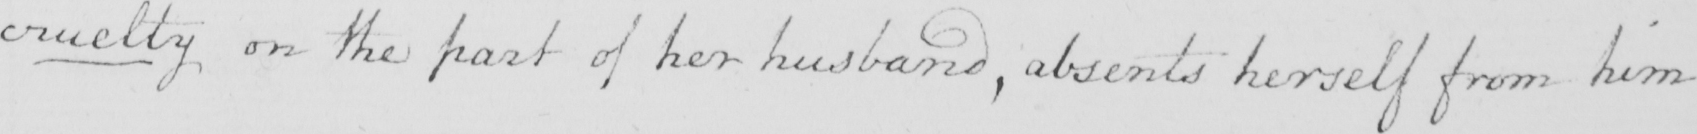What text is written in this handwritten line? cruelty on the part of her husband , absents herself from him 